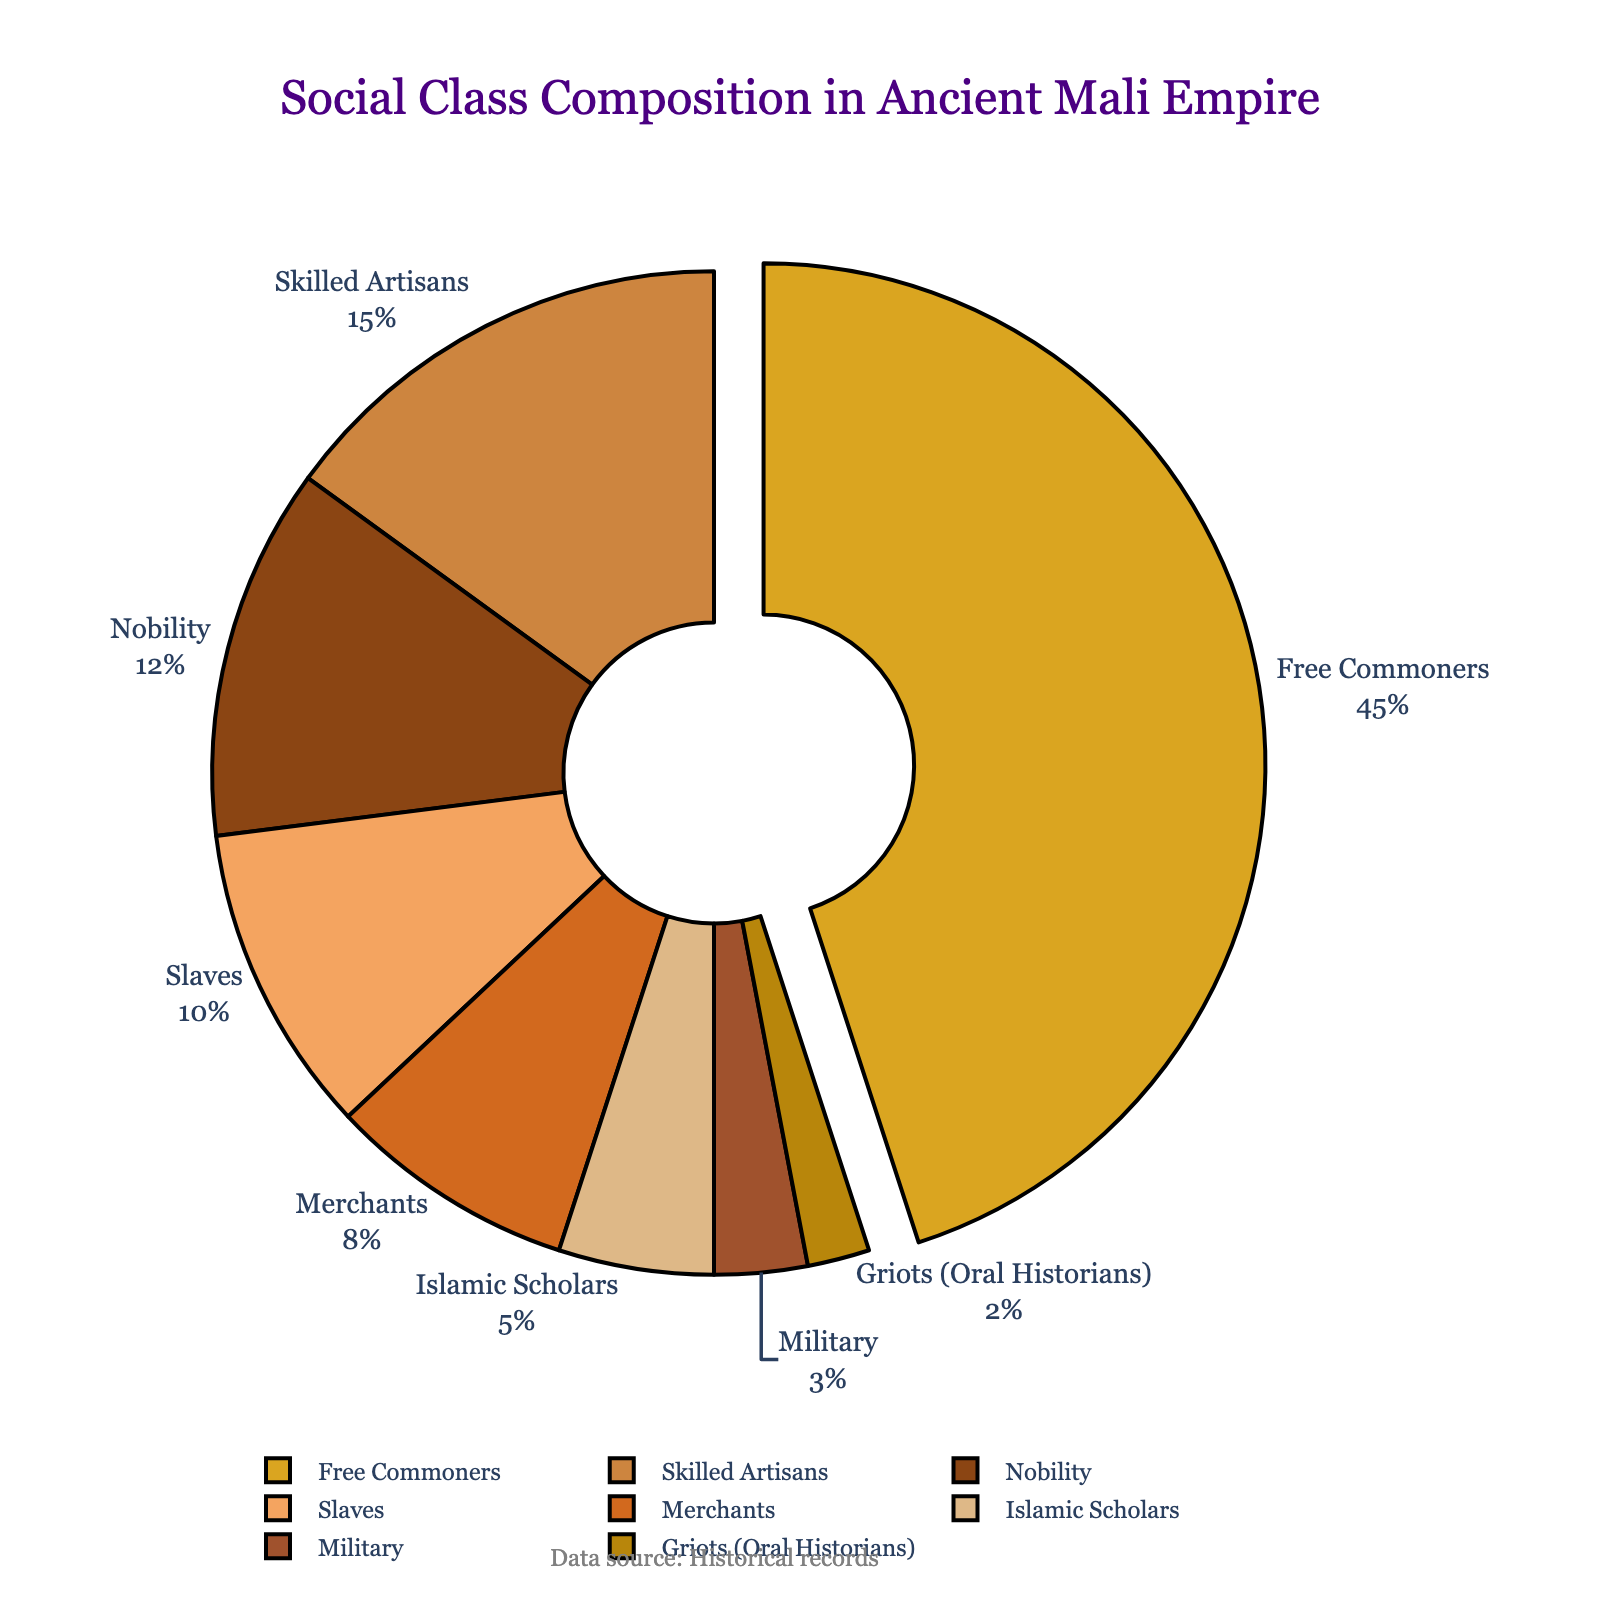What percentage of the population was made up of Nobility and Merchants combined? Add the percentage of Nobility (12%) to the percentage of Merchants (8%). This gives you 12 + 8 = 20%.
Answer: 20% Which social class had the smallest representation in the ancient Mali Empire? Identify the social class with the smallest percentage on the pie chart, which is Griots (Oral Historians) with 2%.
Answer: Griots (Oral Historians) What is the difference in the percentage of Free Commoners and Slaves? Subtract the percentage of Slaves (10%) from the percentage of Free Commoners (45%). This gives you 45 - 10 = 35%.
Answer: 35% Which social class occupies the greatest portion of the pie chart? Look at the section of the pie chart with the largest area; the Free Commoners occupy the greatest portion with 45%.
Answer: Free Commoners If you combined Skilled Artisans and Islamic Scholars, what would be their total percentage? Add the percentage of Skilled Artisans (15%) to the percentage of Islamic Scholars (5%). This gives you 15 + 5 = 20%.
Answer: 20% How much larger is the Free Commoners section compared to the Military section? Subtract the percentage of the Military (3%) from the percentage of Free Commoners (45%). This gives you 45 - 3 = 42%.
Answer: 42% What two social classes together make up the same percentage as Free Commoners? Identify which two classes have percentages adding up to 45%: Nobility (12%) and Skilled Artisans (15%) combined with Merchants (8%) equals 12 + 15 + 8 = 35%, or Skilled Artisans (15%) and Slaves (10%) combined with Merchants (8%) equals 15 + 10 + 8 = 33%, or Nobility (12%) and Skilled Artisans (15%), combined with Islamic Scholars (5%) equals 12 + 15 + 5 = 32%. None exactly match, The correct pairs are Merchants (8%) and Slaves (10%) together with Islamic Scholars (5%) and Griots (2%) equals 8 + 10 + 5 + 2 = 25%. So no exact grouping. Perceive closely to find by logical isolations ( No Pair).
Answer: None Which social class forms the second smallest group? Look at the pie chart section immediately larger than the 2% segment, which belongs to Military at 3%.
Answer: Military What percentage of the society did non-productive classes (Islamic Scholars and Griots) make up together? Add the percentages of Islamic Scholars (5%) and Griots (2%) together. This gives you 5 + 2 = 7%.
Answer: 7% 